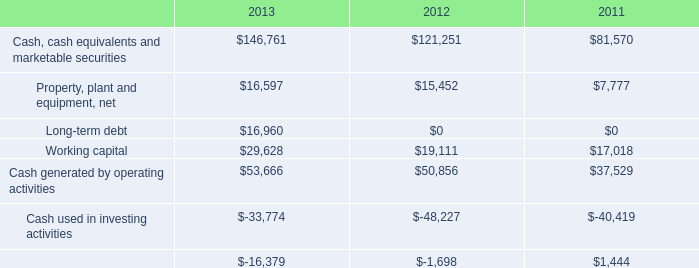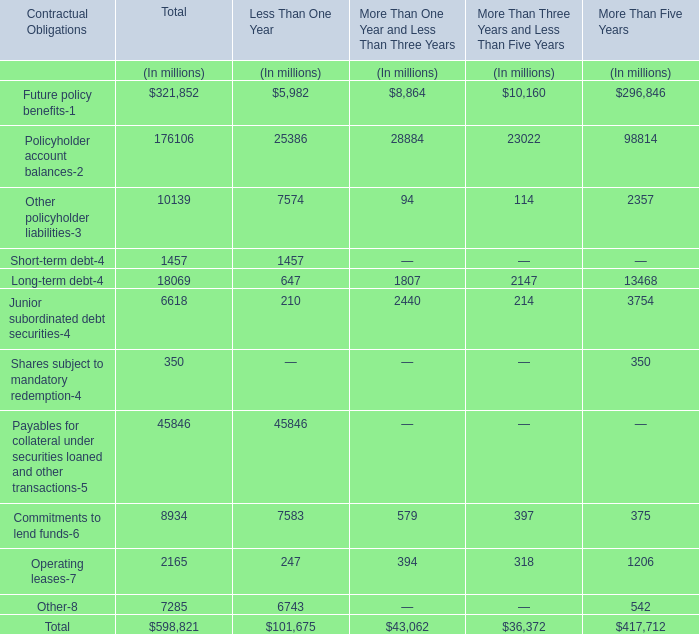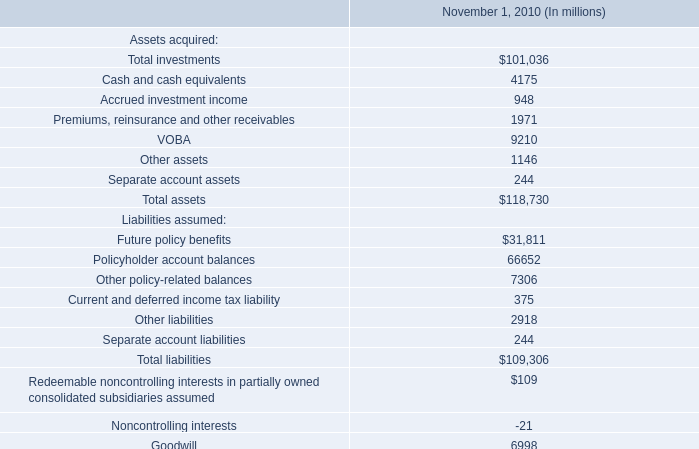What was the sum of More Than One Year and Less Than Three Years without those More Than One Year and Less Than Three Years smaller than 3000? (in million) 
Computations: (8864 + 28884)
Answer: 37748.0. 